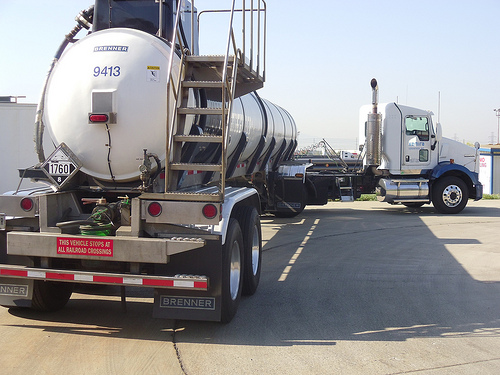<image>
Is there a truck in the road? Yes. The truck is contained within or inside the road, showing a containment relationship. 